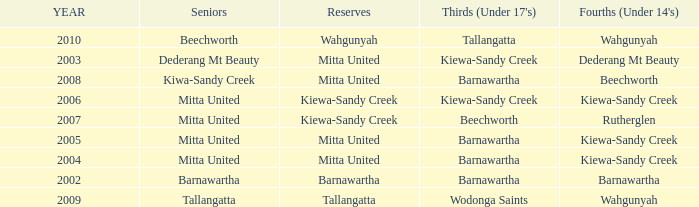Which Thirds (Under 17's) have a Reserve of barnawartha? Barnawartha. 